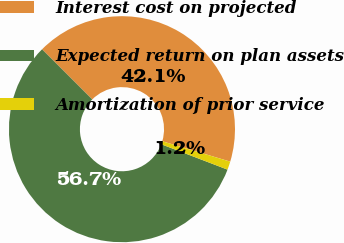<chart> <loc_0><loc_0><loc_500><loc_500><pie_chart><fcel>Interest cost on projected<fcel>Expected return on plan assets<fcel>Amortization of prior service<nl><fcel>42.14%<fcel>56.68%<fcel>1.19%<nl></chart> 